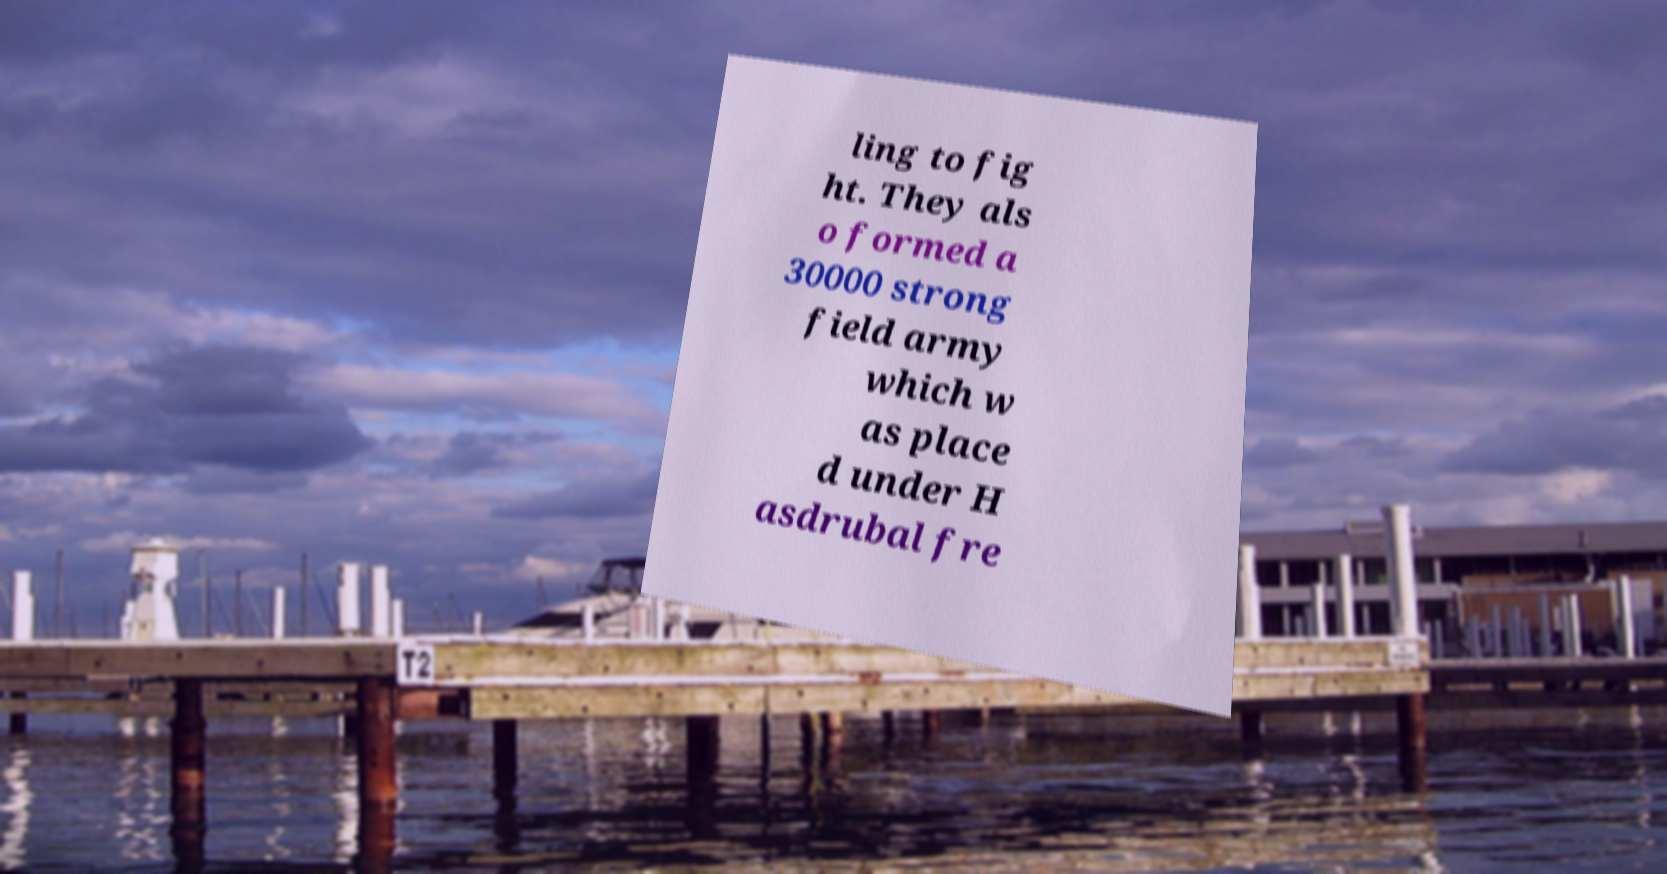I need the written content from this picture converted into text. Can you do that? ling to fig ht. They als o formed a 30000 strong field army which w as place d under H asdrubal fre 